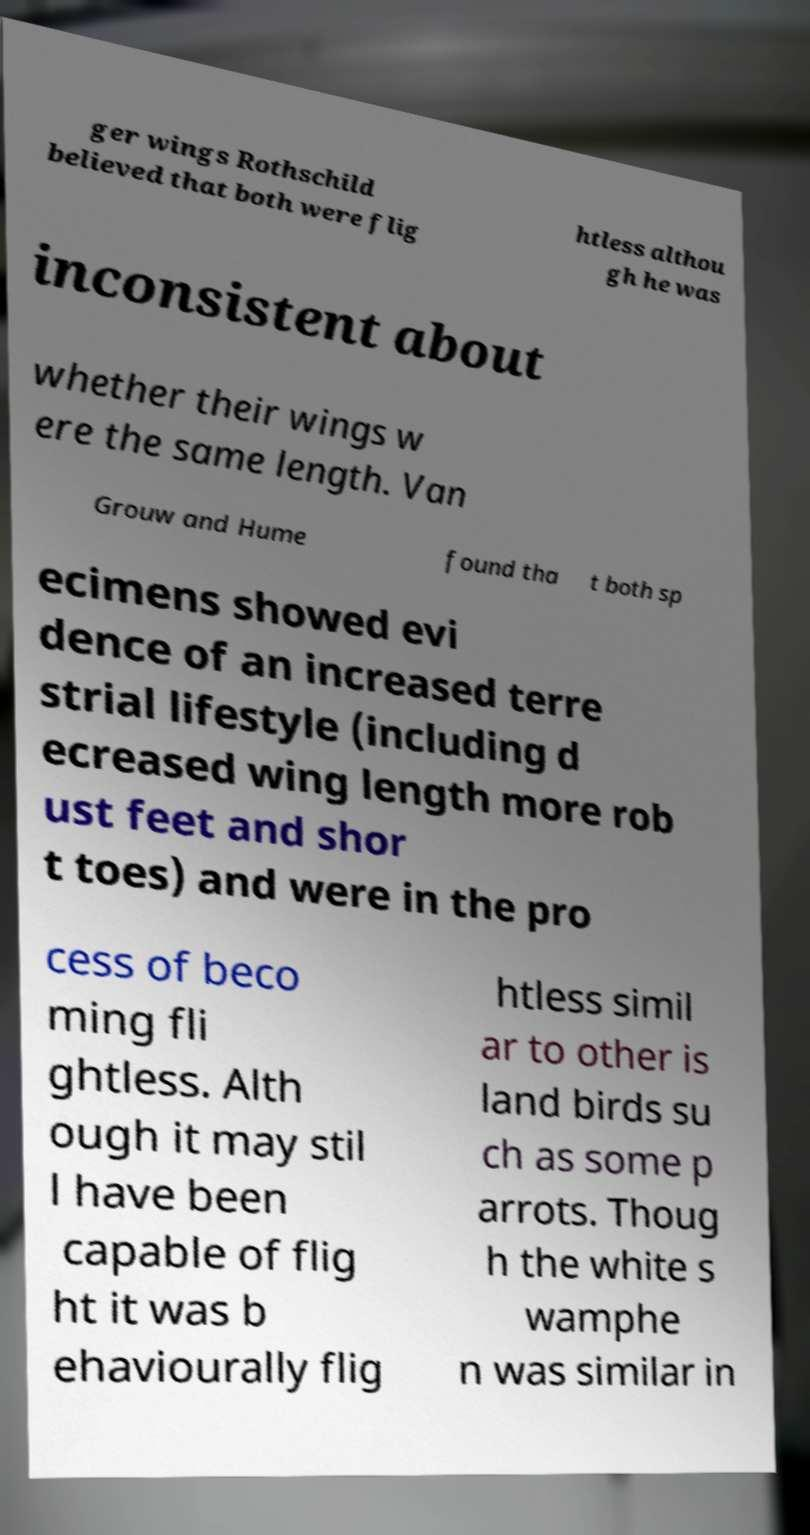Could you extract and type out the text from this image? ger wings Rothschild believed that both were flig htless althou gh he was inconsistent about whether their wings w ere the same length. Van Grouw and Hume found tha t both sp ecimens showed evi dence of an increased terre strial lifestyle (including d ecreased wing length more rob ust feet and shor t toes) and were in the pro cess of beco ming fli ghtless. Alth ough it may stil l have been capable of flig ht it was b ehaviourally flig htless simil ar to other is land birds su ch as some p arrots. Thoug h the white s wamphe n was similar in 